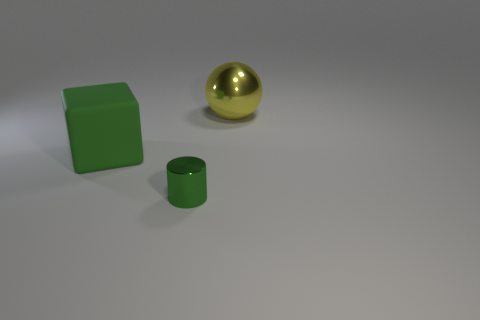There is a tiny green cylinder; are there any objects on the right side of it?
Provide a succinct answer. Yes. What is the size of the metal cylinder that is the same color as the big matte block?
Ensure brevity in your answer.  Small. Is there another yellow sphere made of the same material as the yellow ball?
Give a very brief answer. No. The big cube is what color?
Provide a succinct answer. Green. There is a metallic object that is behind the small green metal cylinder; does it have the same shape as the big green object?
Offer a very short reply. No. What shape is the large thing that is left of the green thing that is to the right of the large object to the left of the large yellow object?
Your answer should be very brief. Cube. What material is the big object that is in front of the big yellow metal object?
Provide a short and direct response. Rubber. What is the color of the object that is the same size as the cube?
Provide a succinct answer. Yellow. How many other things are the same shape as the big green rubber thing?
Your answer should be very brief. 0. Is the size of the cylinder the same as the block?
Provide a succinct answer. No. 